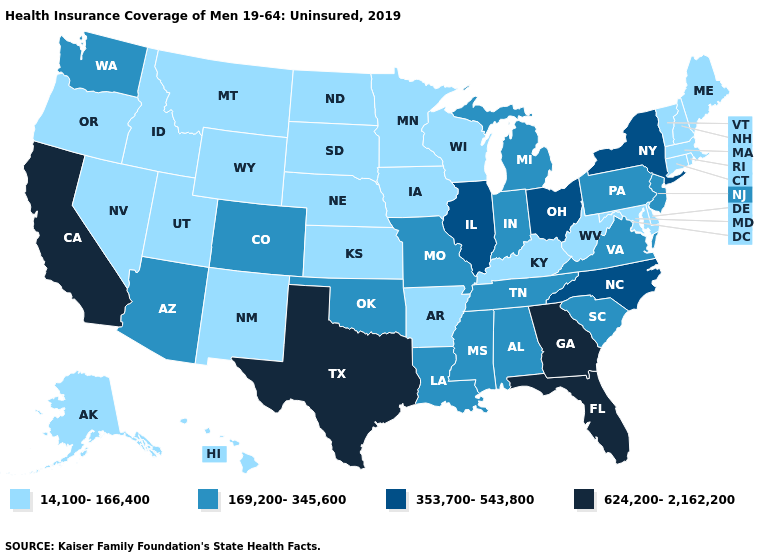How many symbols are there in the legend?
Keep it brief. 4. What is the lowest value in the USA?
Short answer required. 14,100-166,400. What is the value of Colorado?
Keep it brief. 169,200-345,600. Does Pennsylvania have the highest value in the Northeast?
Keep it brief. No. Name the states that have a value in the range 14,100-166,400?
Concise answer only. Alaska, Arkansas, Connecticut, Delaware, Hawaii, Idaho, Iowa, Kansas, Kentucky, Maine, Maryland, Massachusetts, Minnesota, Montana, Nebraska, Nevada, New Hampshire, New Mexico, North Dakota, Oregon, Rhode Island, South Dakota, Utah, Vermont, West Virginia, Wisconsin, Wyoming. Among the states that border Utah , which have the lowest value?
Quick response, please. Idaho, Nevada, New Mexico, Wyoming. Which states have the lowest value in the Northeast?
Write a very short answer. Connecticut, Maine, Massachusetts, New Hampshire, Rhode Island, Vermont. What is the lowest value in the Northeast?
Concise answer only. 14,100-166,400. Name the states that have a value in the range 353,700-543,800?
Quick response, please. Illinois, New York, North Carolina, Ohio. Does West Virginia have a lower value than Illinois?
Keep it brief. Yes. Name the states that have a value in the range 624,200-2,162,200?
Keep it brief. California, Florida, Georgia, Texas. What is the value of Mississippi?
Quick response, please. 169,200-345,600. Name the states that have a value in the range 169,200-345,600?
Short answer required. Alabama, Arizona, Colorado, Indiana, Louisiana, Michigan, Mississippi, Missouri, New Jersey, Oklahoma, Pennsylvania, South Carolina, Tennessee, Virginia, Washington. Does Texas have the highest value in the USA?
Answer briefly. Yes. Which states have the lowest value in the USA?
Answer briefly. Alaska, Arkansas, Connecticut, Delaware, Hawaii, Idaho, Iowa, Kansas, Kentucky, Maine, Maryland, Massachusetts, Minnesota, Montana, Nebraska, Nevada, New Hampshire, New Mexico, North Dakota, Oregon, Rhode Island, South Dakota, Utah, Vermont, West Virginia, Wisconsin, Wyoming. 